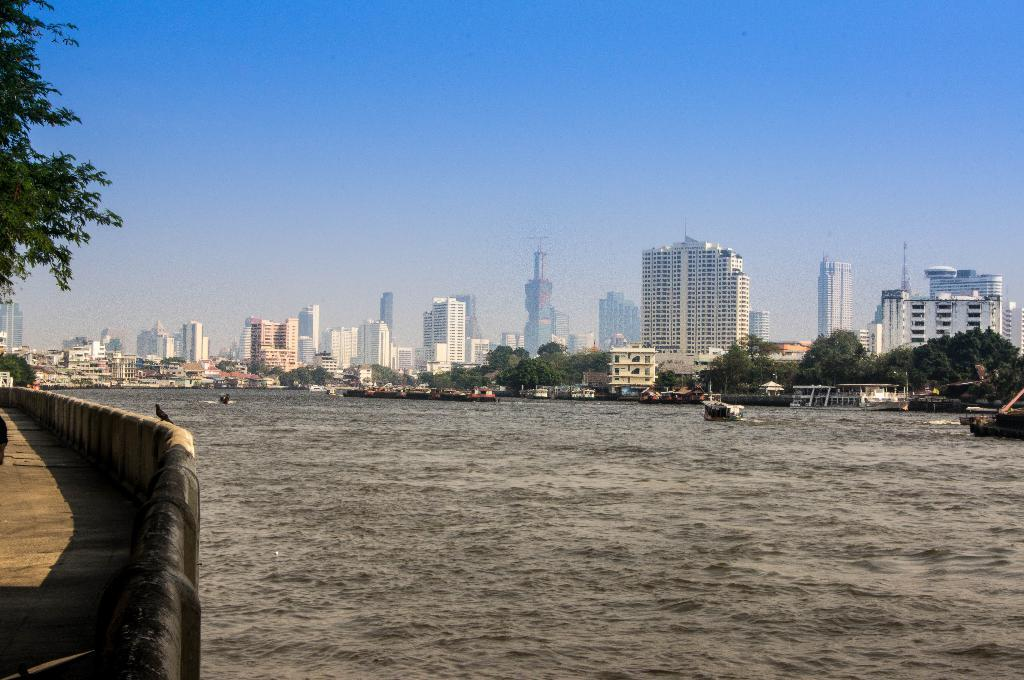What is on the water in the image? There are boats on the water in the image. What can be seen in the distance behind the boats? There are buildings and trees in the background of the image. What is your dad doing in the image? There is no person, including a dad, present in the image. 